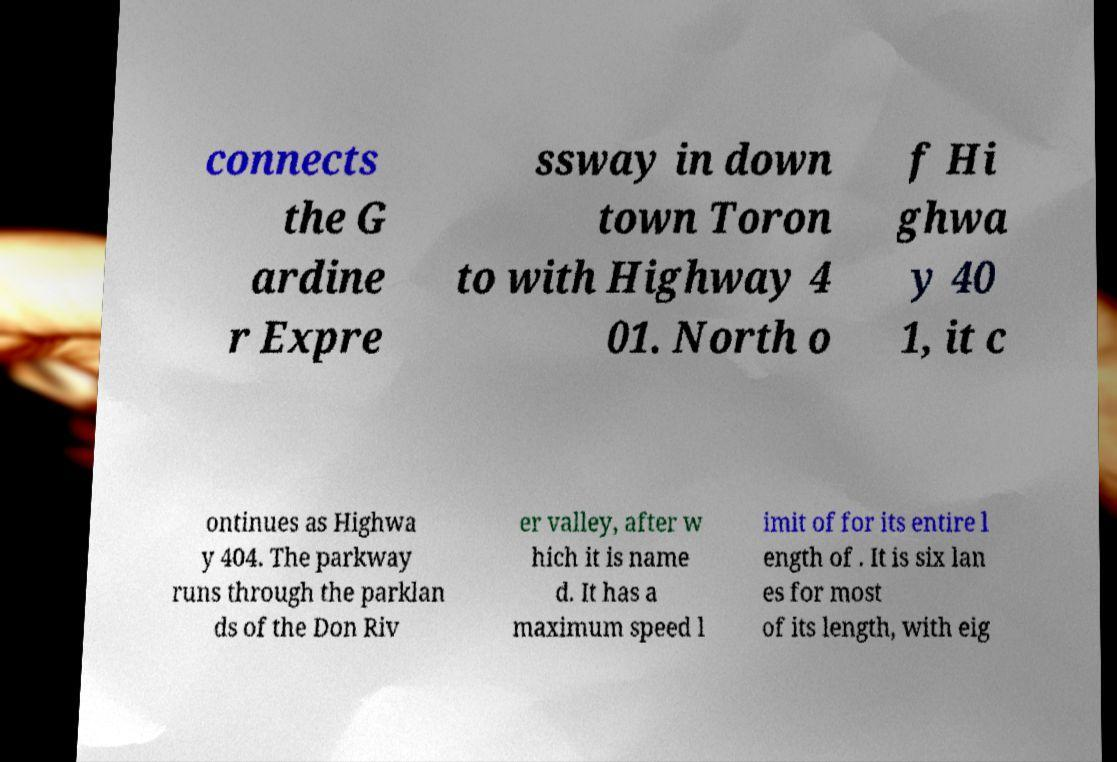Please read and relay the text visible in this image. What does it say? connects the G ardine r Expre ssway in down town Toron to with Highway 4 01. North o f Hi ghwa y 40 1, it c ontinues as Highwa y 404. The parkway runs through the parklan ds of the Don Riv er valley, after w hich it is name d. It has a maximum speed l imit of for its entire l ength of . It is six lan es for most of its length, with eig 